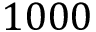Convert formula to latex. <formula><loc_0><loc_0><loc_500><loc_500>1 0 0 0</formula> 